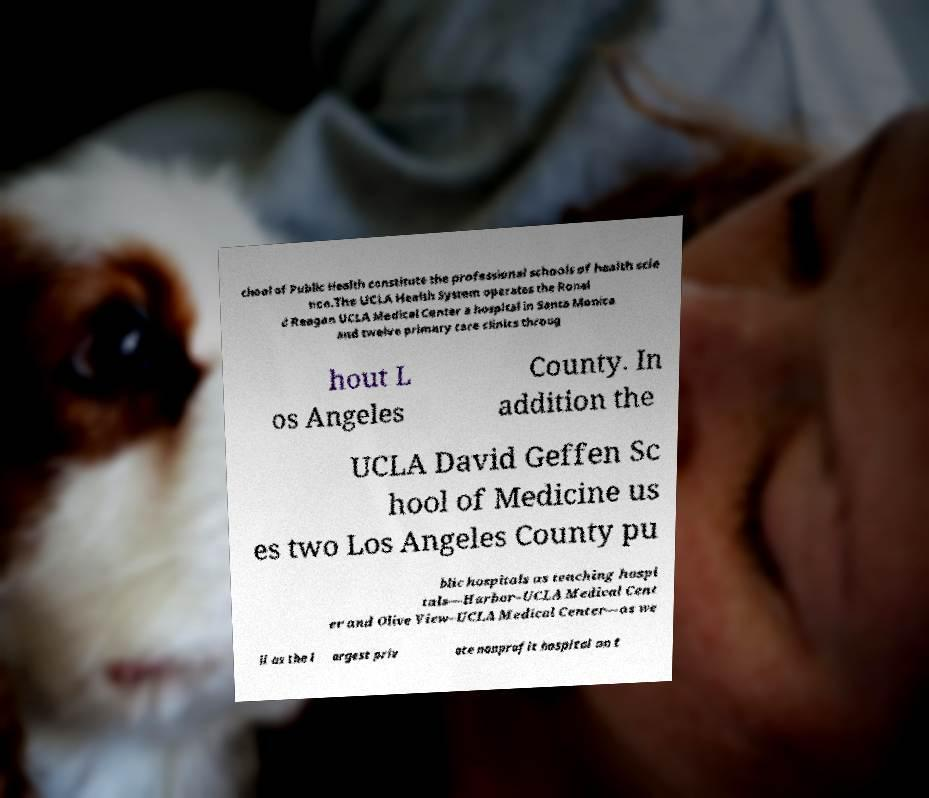For documentation purposes, I need the text within this image transcribed. Could you provide that? chool of Public Health constitute the professional schools of health scie nce.The UCLA Health System operates the Ronal d Reagan UCLA Medical Center a hospital in Santa Monica and twelve primary care clinics throug hout L os Angeles County. In addition the UCLA David Geffen Sc hool of Medicine us es two Los Angeles County pu blic hospitals as teaching hospi tals—Harbor–UCLA Medical Cent er and Olive View–UCLA Medical Center—as we ll as the l argest priv ate nonprofit hospital on t 